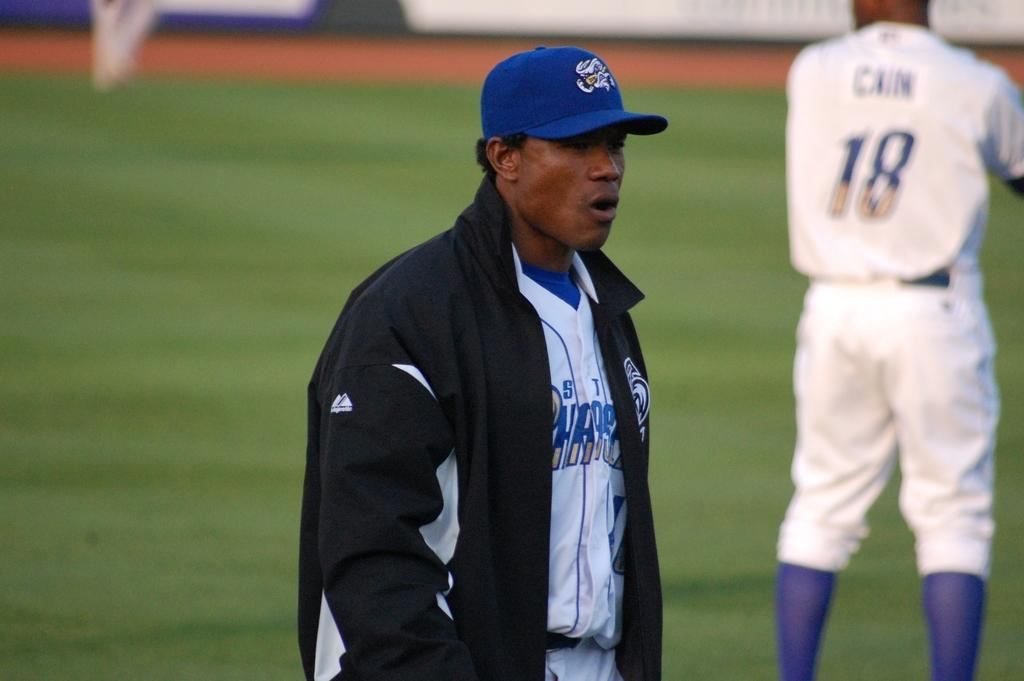<image>
Offer a succinct explanation of the picture presented. Baseball player wearing number 18 getting ready to pitch. 